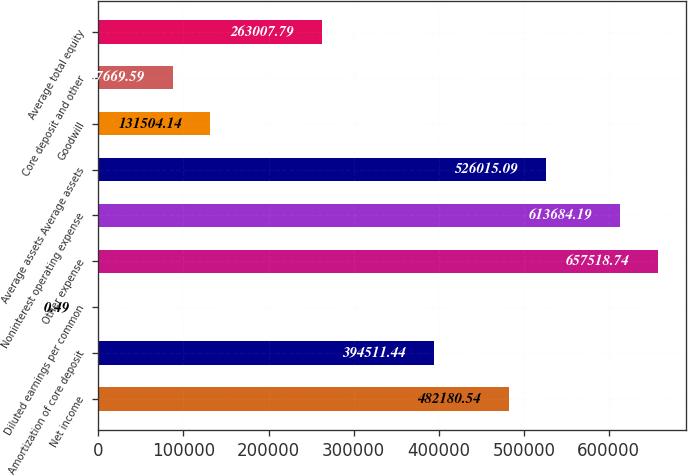Convert chart to OTSL. <chart><loc_0><loc_0><loc_500><loc_500><bar_chart><fcel>Net income<fcel>Amortization of core deposit<fcel>Diluted earnings per common<fcel>Other expense<fcel>Noninterest operating expense<fcel>Average assets Average assets<fcel>Goodwill<fcel>Core deposit and other<fcel>Average total equity<nl><fcel>482181<fcel>394511<fcel>0.49<fcel>657519<fcel>613684<fcel>526015<fcel>131504<fcel>87669.6<fcel>263008<nl></chart> 